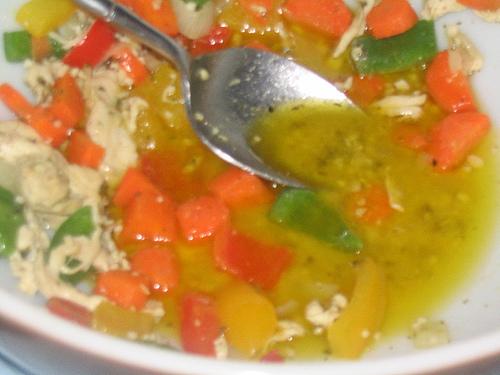What is the spoon made of?
Short answer required. Metal. What is the green food?
Short answer required. Peppers. What kind of soup is this?
Answer briefly. Vegetable. What utensil is this?
Quick response, please. Spoon. What kind of spoon is used?
Answer briefly. Teaspoon. 